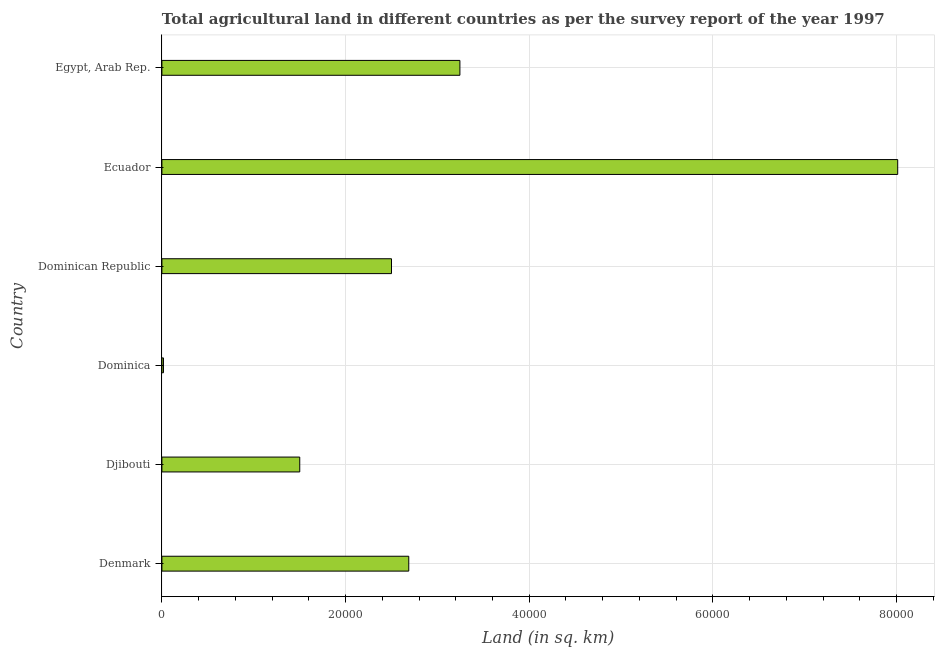Does the graph contain any zero values?
Ensure brevity in your answer.  No. What is the title of the graph?
Give a very brief answer. Total agricultural land in different countries as per the survey report of the year 1997. What is the label or title of the X-axis?
Offer a very short reply. Land (in sq. km). What is the label or title of the Y-axis?
Your answer should be very brief. Country. What is the agricultural land in Dominican Republic?
Provide a short and direct response. 2.50e+04. Across all countries, what is the maximum agricultural land?
Make the answer very short. 8.01e+04. Across all countries, what is the minimum agricultural land?
Offer a terse response. 170. In which country was the agricultural land maximum?
Offer a very short reply. Ecuador. In which country was the agricultural land minimum?
Provide a succinct answer. Dominica. What is the sum of the agricultural land?
Provide a succinct answer. 1.80e+05. What is the difference between the agricultural land in Dominica and Ecuador?
Ensure brevity in your answer.  -8.00e+04. What is the average agricultural land per country?
Your answer should be very brief. 2.99e+04. What is the median agricultural land?
Your response must be concise. 2.59e+04. In how many countries, is the agricultural land greater than 4000 sq. km?
Provide a short and direct response. 5. What is the ratio of the agricultural land in Ecuador to that in Egypt, Arab Rep.?
Give a very brief answer. 2.47. Is the agricultural land in Dominica less than that in Dominican Republic?
Your answer should be very brief. Yes. Is the difference between the agricultural land in Dominica and Dominican Republic greater than the difference between any two countries?
Keep it short and to the point. No. What is the difference between the highest and the second highest agricultural land?
Ensure brevity in your answer.  4.77e+04. Is the sum of the agricultural land in Djibouti and Dominican Republic greater than the maximum agricultural land across all countries?
Make the answer very short. No. What is the difference between the highest and the lowest agricultural land?
Make the answer very short. 8.00e+04. Are all the bars in the graph horizontal?
Provide a short and direct response. Yes. How many countries are there in the graph?
Your answer should be compact. 6. What is the difference between two consecutive major ticks on the X-axis?
Make the answer very short. 2.00e+04. Are the values on the major ticks of X-axis written in scientific E-notation?
Keep it short and to the point. No. What is the Land (in sq. km) in Denmark?
Provide a succinct answer. 2.69e+04. What is the Land (in sq. km) of Djibouti?
Offer a terse response. 1.50e+04. What is the Land (in sq. km) in Dominica?
Ensure brevity in your answer.  170. What is the Land (in sq. km) in Dominican Republic?
Provide a short and direct response. 2.50e+04. What is the Land (in sq. km) of Ecuador?
Offer a very short reply. 8.01e+04. What is the Land (in sq. km) in Egypt, Arab Rep.?
Keep it short and to the point. 3.24e+04. What is the difference between the Land (in sq. km) in Denmark and Djibouti?
Your response must be concise. 1.19e+04. What is the difference between the Land (in sq. km) in Denmark and Dominica?
Give a very brief answer. 2.67e+04. What is the difference between the Land (in sq. km) in Denmark and Dominican Republic?
Your response must be concise. 1880. What is the difference between the Land (in sq. km) in Denmark and Ecuador?
Give a very brief answer. -5.32e+04. What is the difference between the Land (in sq. km) in Denmark and Egypt, Arab Rep.?
Give a very brief answer. -5569.2. What is the difference between the Land (in sq. km) in Djibouti and Dominica?
Your response must be concise. 1.48e+04. What is the difference between the Land (in sq. km) in Djibouti and Dominican Republic?
Offer a terse response. -9990. What is the difference between the Land (in sq. km) in Djibouti and Ecuador?
Keep it short and to the point. -6.51e+04. What is the difference between the Land (in sq. km) in Djibouti and Egypt, Arab Rep.?
Your answer should be very brief. -1.74e+04. What is the difference between the Land (in sq. km) in Dominica and Dominican Republic?
Your answer should be very brief. -2.48e+04. What is the difference between the Land (in sq. km) in Dominica and Ecuador?
Your answer should be compact. -8.00e+04. What is the difference between the Land (in sq. km) in Dominica and Egypt, Arab Rep.?
Ensure brevity in your answer.  -3.23e+04. What is the difference between the Land (in sq. km) in Dominican Republic and Ecuador?
Keep it short and to the point. -5.51e+04. What is the difference between the Land (in sq. km) in Dominican Republic and Egypt, Arab Rep.?
Provide a short and direct response. -7449.2. What is the difference between the Land (in sq. km) in Ecuador and Egypt, Arab Rep.?
Your answer should be compact. 4.77e+04. What is the ratio of the Land (in sq. km) in Denmark to that in Djibouti?
Your answer should be compact. 1.79. What is the ratio of the Land (in sq. km) in Denmark to that in Dominica?
Your answer should be very brief. 158.12. What is the ratio of the Land (in sq. km) in Denmark to that in Dominican Republic?
Ensure brevity in your answer.  1.07. What is the ratio of the Land (in sq. km) in Denmark to that in Ecuador?
Provide a short and direct response. 0.34. What is the ratio of the Land (in sq. km) in Denmark to that in Egypt, Arab Rep.?
Keep it short and to the point. 0.83. What is the ratio of the Land (in sq. km) in Djibouti to that in Dominica?
Your answer should be compact. 88.29. What is the ratio of the Land (in sq. km) in Djibouti to that in Dominican Republic?
Provide a succinct answer. 0.6. What is the ratio of the Land (in sq. km) in Djibouti to that in Ecuador?
Provide a short and direct response. 0.19. What is the ratio of the Land (in sq. km) in Djibouti to that in Egypt, Arab Rep.?
Keep it short and to the point. 0.46. What is the ratio of the Land (in sq. km) in Dominica to that in Dominican Republic?
Offer a terse response. 0.01. What is the ratio of the Land (in sq. km) in Dominica to that in Ecuador?
Provide a short and direct response. 0. What is the ratio of the Land (in sq. km) in Dominica to that in Egypt, Arab Rep.?
Give a very brief answer. 0.01. What is the ratio of the Land (in sq. km) in Dominican Republic to that in Ecuador?
Ensure brevity in your answer.  0.31. What is the ratio of the Land (in sq. km) in Dominican Republic to that in Egypt, Arab Rep.?
Make the answer very short. 0.77. What is the ratio of the Land (in sq. km) in Ecuador to that in Egypt, Arab Rep.?
Give a very brief answer. 2.47. 